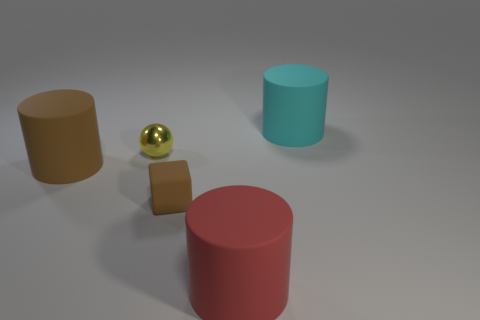There is a large rubber thing in front of the tiny object in front of the yellow metallic thing; what color is it?
Offer a terse response. Red. What number of metallic objects are either small red objects or brown blocks?
Your answer should be compact. 0. Is the material of the big thing to the left of the metallic object the same as the tiny thing behind the large brown thing?
Ensure brevity in your answer.  No. Is there a brown matte sphere?
Offer a very short reply. No. Do the big thing that is on the left side of the tiny block and the object that is to the right of the big red cylinder have the same shape?
Provide a short and direct response. Yes. Are there any red things that have the same material as the yellow object?
Provide a succinct answer. No. Is the material of the brown thing left of the small matte object the same as the small cube?
Give a very brief answer. Yes. Are there more brown matte objects to the left of the brown rubber cube than brown blocks that are on the left side of the brown cylinder?
Give a very brief answer. Yes. There is a rubber cube that is the same size as the yellow sphere; what color is it?
Keep it short and to the point. Brown. Is there a ball of the same color as the rubber cube?
Your answer should be very brief. No. 